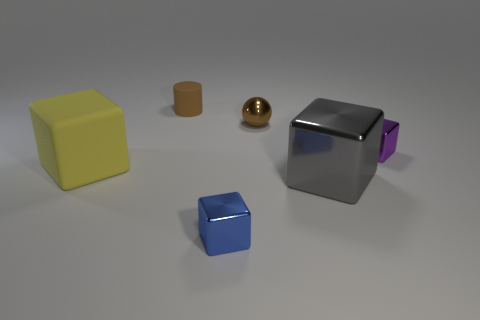Subtract all large shiny blocks. How many blocks are left? 3 Add 2 blue things. How many objects exist? 8 Subtract all purple cubes. How many cubes are left? 3 Subtract all cubes. How many objects are left? 2 Subtract 1 yellow blocks. How many objects are left? 5 Subtract 3 cubes. How many cubes are left? 1 Subtract all green blocks. Subtract all gray cylinders. How many blocks are left? 4 Subtract all brown shiny spheres. Subtract all cubes. How many objects are left? 1 Add 5 small matte objects. How many small matte objects are left? 6 Add 6 purple metallic objects. How many purple metallic objects exist? 7 